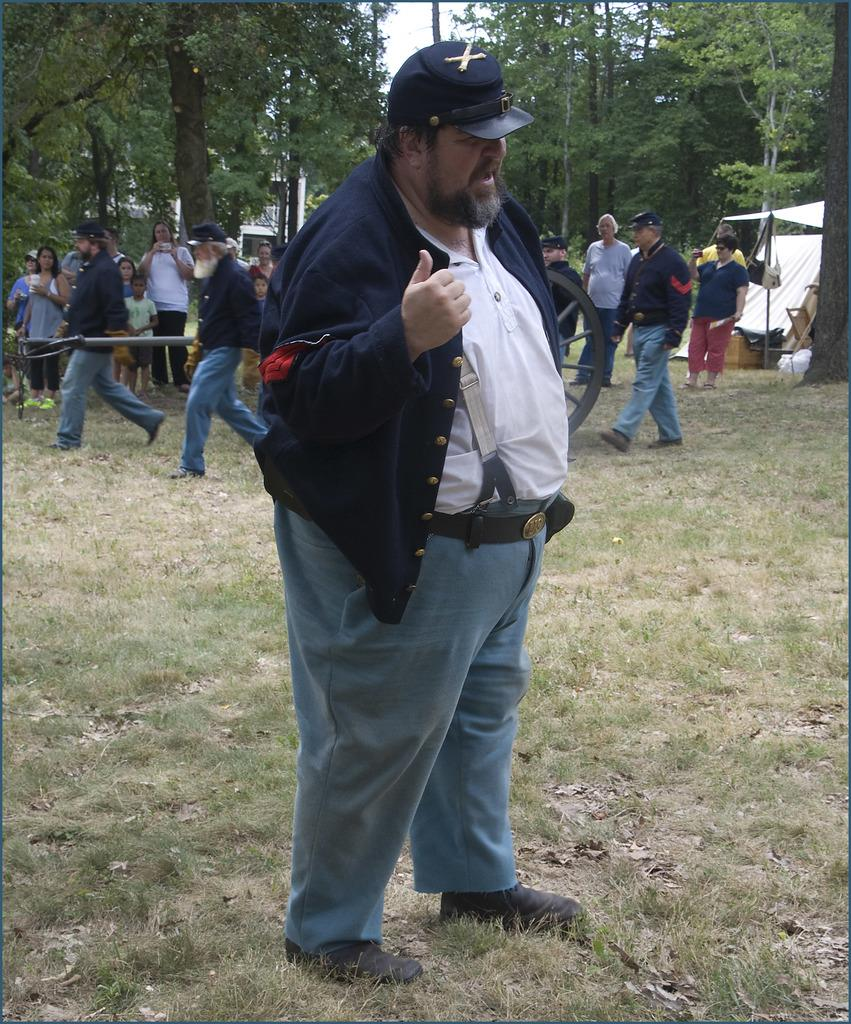Who is present in the image? There is a man in the image. What is the man wearing on his head? The man is wearing a cap. Where is the man standing in the image? The man is standing on the ground. What can be seen in the background of the image? There is a group of people, trees, a tent, and the sky visible in the background of the image. What type of thrill can be seen in the image? There is no specific thrill depicted in the image; it features a man standing on the ground with a cap, surrounded by a group of people, trees, a tent, and the sky. Is the queen present in the image? There is no mention of a queen or any royal figure in the image; it features a man standing on the ground with a cap, surrounded by a group of people, trees, a tent, and the sky. 